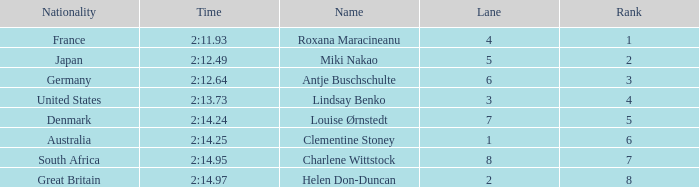Could you parse the entire table? {'header': ['Nationality', 'Time', 'Name', 'Lane', 'Rank'], 'rows': [['France', '2:11.93', 'Roxana Maracineanu', '4', '1'], ['Japan', '2:12.49', 'Miki Nakao', '5', '2'], ['Germany', '2:12.64', 'Antje Buschschulte', '6', '3'], ['United States', '2:13.73', 'Lindsay Benko', '3', '4'], ['Denmark', '2:14.24', 'Louise Ørnstedt', '7', '5'], ['Australia', '2:14.25', 'Clementine Stoney', '1', '6'], ['South Africa', '2:14.95', 'Charlene Wittstock', '8', '7'], ['Great Britain', '2:14.97', 'Helen Don-Duncan', '2', '8']]} What is the number of lane with a rank more than 2 for louise ørnstedt? 1.0. 